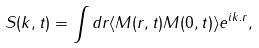Convert formula to latex. <formula><loc_0><loc_0><loc_500><loc_500>S ( { k } , t ) = \int d { r } \langle M ( { r } , t ) M ( 0 , t ) \rangle e ^ { i { k } . { r } } ,</formula> 